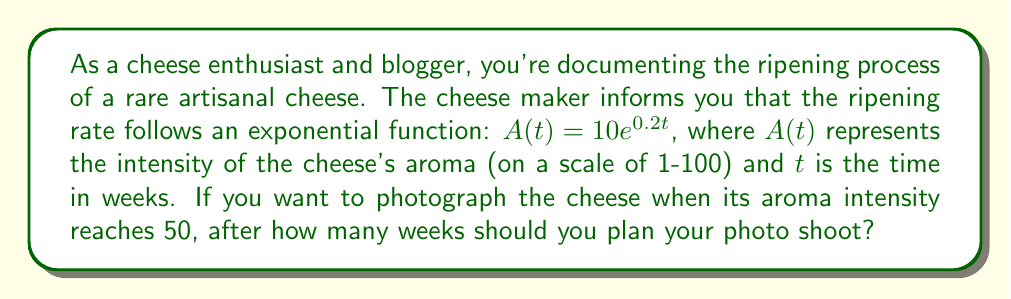Provide a solution to this math problem. To solve this problem, we need to use the given exponential function and solve for $t$ when $A(t) = 50$. Let's break it down step-by-step:

1) The given function is $A(t) = 10e^{0.2t}$

2) We want to find $t$ when $A(t) = 50$, so we set up the equation:
   $50 = 10e^{0.2t}$

3) Divide both sides by 10:
   $5 = e^{0.2t}$

4) Take the natural logarithm of both sides:
   $\ln(5) = \ln(e^{0.2t})$

5) Simplify the right side using the property of logarithms:
   $\ln(5) = 0.2t$

6) Divide both sides by 0.2:
   $\frac{\ln(5)}{0.2} = t$

7) Calculate the value:
   $t \approx 8.0472$ weeks

Therefore, you should plan your photo shoot approximately 8.05 weeks after the cheese begins ripening.
Answer: $8.05$ weeks 